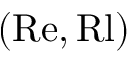Convert formula to latex. <formula><loc_0><loc_0><loc_500><loc_500>( R e , R l )</formula> 